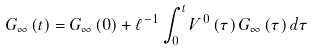Convert formula to latex. <formula><loc_0><loc_0><loc_500><loc_500>G _ { \infty } \left ( t \right ) = G _ { \infty } \left ( 0 \right ) + \ell ^ { - 1 } \int _ { 0 } ^ { t } V ^ { 0 } \left ( \tau \right ) G _ { \infty } \left ( \tau \right ) d \tau</formula> 